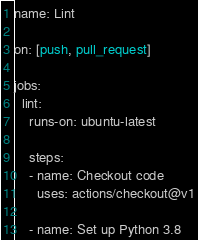<code> <loc_0><loc_0><loc_500><loc_500><_YAML_>name: Lint

on: [push, pull_request]

jobs:
  lint:
    runs-on: ubuntu-latest

    steps:
    - name: Checkout code
      uses: actions/checkout@v1

    - name: Set up Python 3.8</code> 